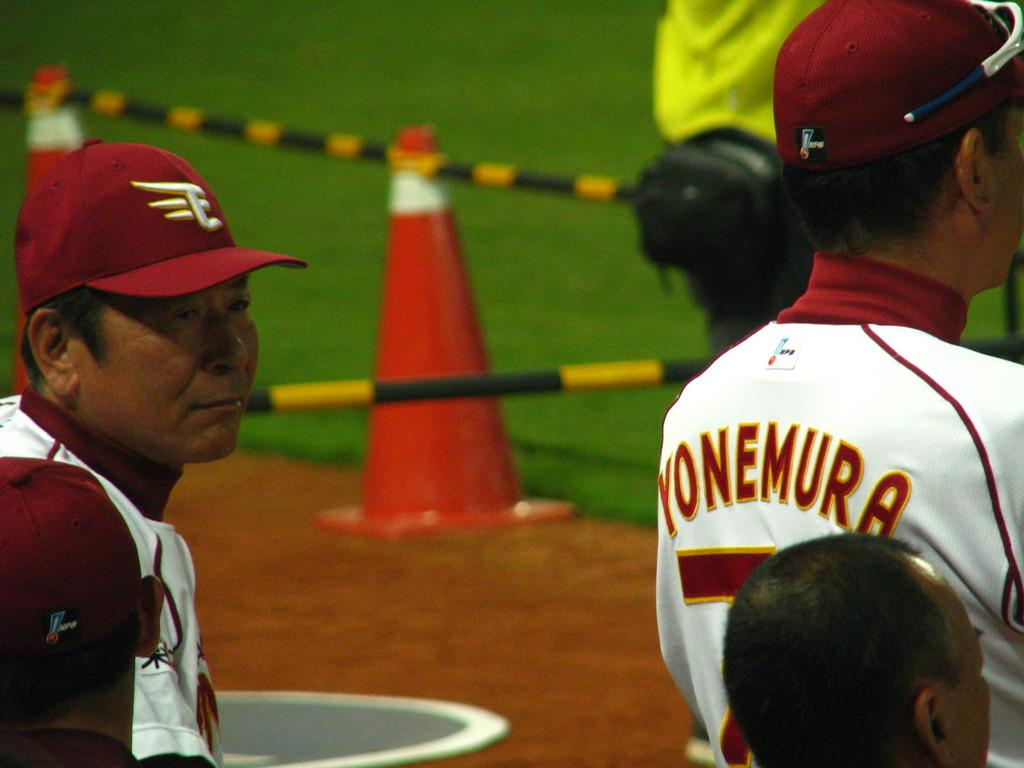<image>
Describe the image concisely. Baseball player wearing a number 7 is watching on the field. 